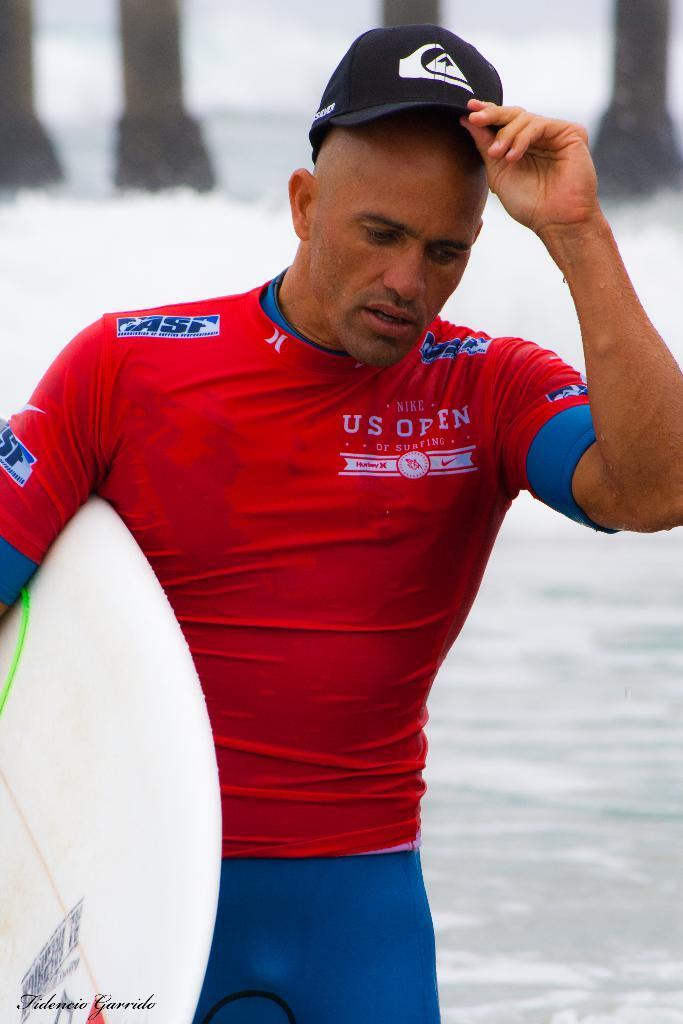What can be seen in the image? There is a person in the image. Can you describe the person's attire? The person is wearing colorful clothes. What headwear is the person wearing? The person is wearing a cap. Where is the person standing in the image? The person is standing in front of the water. What is the person holding in the image? The person is holding a surface boat. What type of bulb is being used to light up the sea in the image? There is no mention of a sea or a bulb in the image; it features a person standing in front of the water and holding a surface boat. 